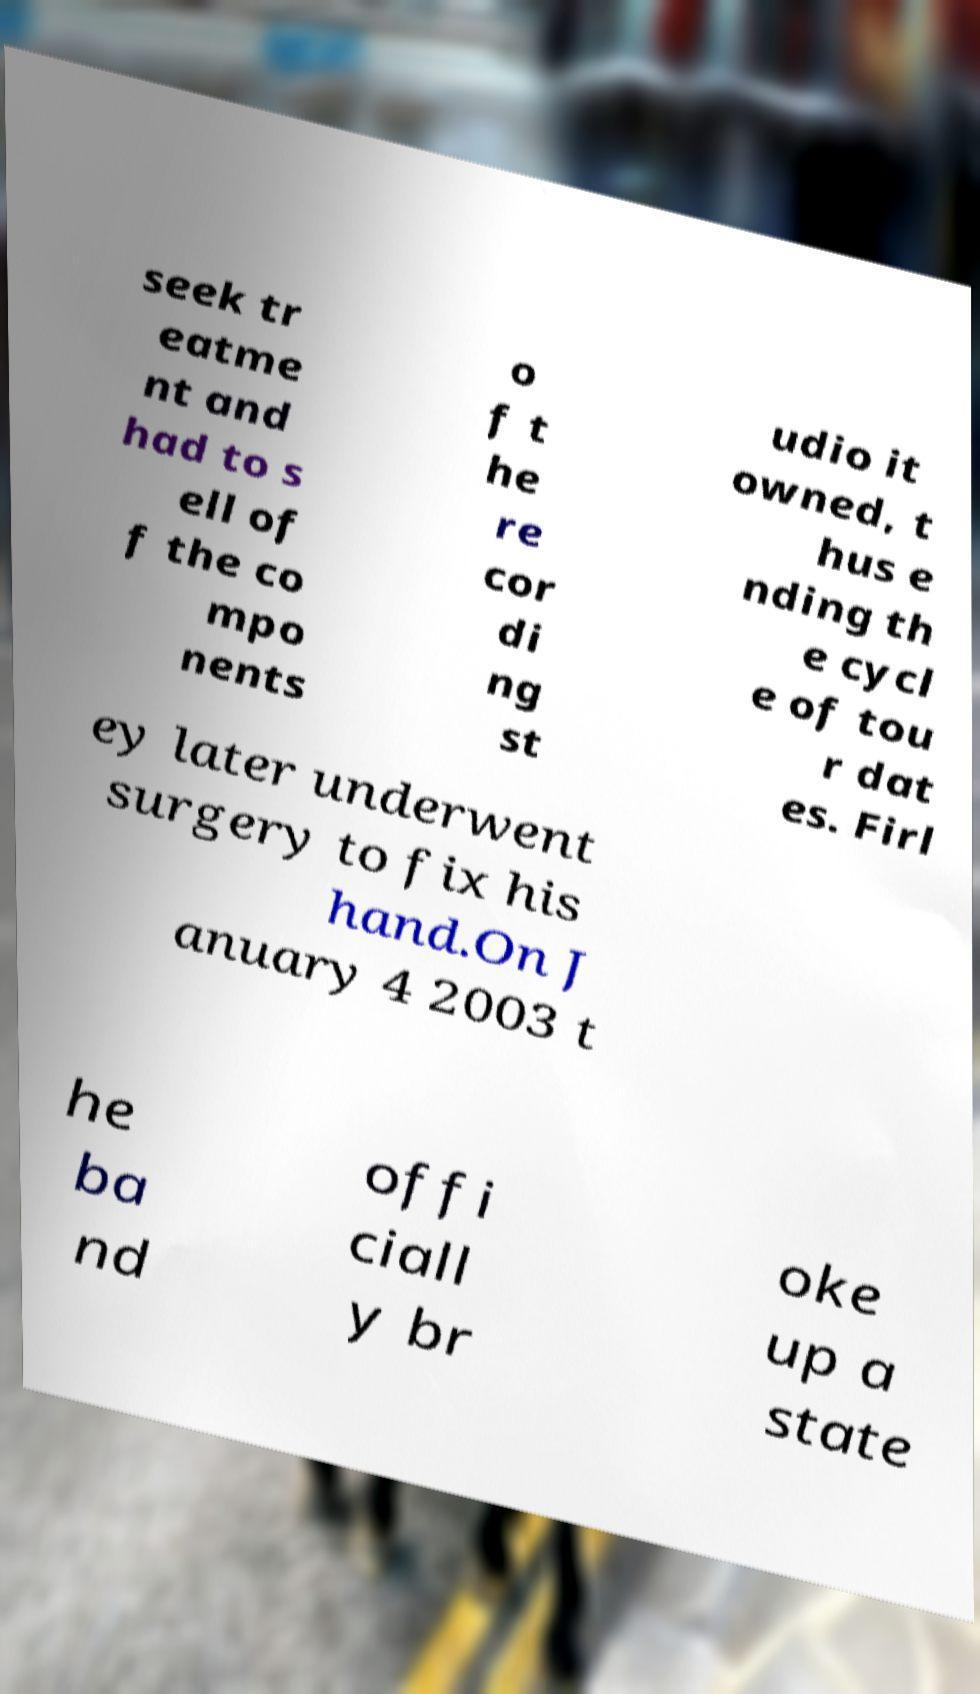Could you assist in decoding the text presented in this image and type it out clearly? seek tr eatme nt and had to s ell of f the co mpo nents o f t he re cor di ng st udio it owned, t hus e nding th e cycl e of tou r dat es. Firl ey later underwent surgery to fix his hand.On J anuary 4 2003 t he ba nd offi ciall y br oke up a state 